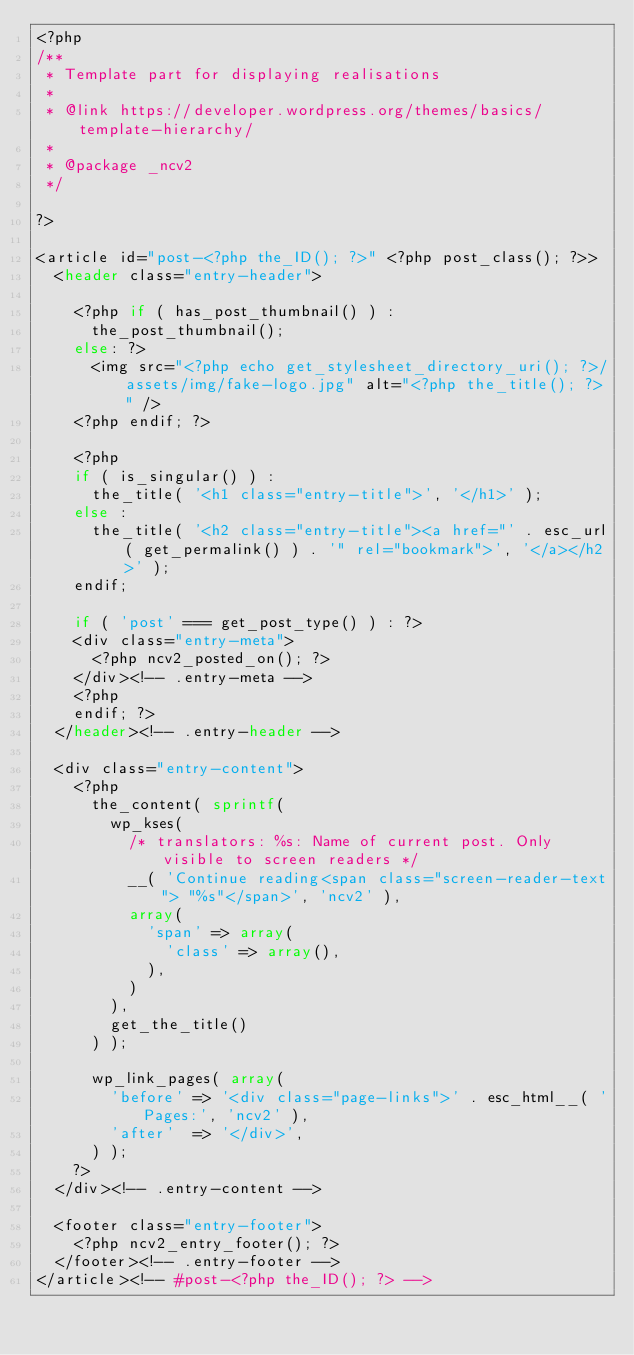Convert code to text. <code><loc_0><loc_0><loc_500><loc_500><_PHP_><?php
/**
 * Template part for displaying realisations
 *
 * @link https://developer.wordpress.org/themes/basics/template-hierarchy/
 *
 * @package _ncv2
 */

?>

<article id="post-<?php the_ID(); ?>" <?php post_class(); ?>>
	<header class="entry-header">

    <?php if ( has_post_thumbnail() ) :
      the_post_thumbnail();
    else: ?>
      <img src="<?php echo get_stylesheet_directory_uri(); ?>/assets/img/fake-logo.jpg" alt="<?php the_title(); ?>" />
    <?php endif; ?>

		<?php
		if ( is_singular() ) :
			the_title( '<h1 class="entry-title">', '</h1>' );
		else :
			the_title( '<h2 class="entry-title"><a href="' . esc_url( get_permalink() ) . '" rel="bookmark">', '</a></h2>' );
		endif;

		if ( 'post' === get_post_type() ) : ?>
		<div class="entry-meta">
			<?php ncv2_posted_on(); ?>
		</div><!-- .entry-meta -->
		<?php
		endif; ?>
	</header><!-- .entry-header -->

	<div class="entry-content">
		<?php
			the_content( sprintf(
				wp_kses(
					/* translators: %s: Name of current post. Only visible to screen readers */
					__( 'Continue reading<span class="screen-reader-text"> "%s"</span>', 'ncv2' ),
					array(
						'span' => array(
							'class' => array(),
						),
					)
				),
				get_the_title()
			) );

			wp_link_pages( array(
				'before' => '<div class="page-links">' . esc_html__( 'Pages:', 'ncv2' ),
				'after'  => '</div>',
			) );
		?>
	</div><!-- .entry-content -->

	<footer class="entry-footer">
		<?php ncv2_entry_footer(); ?>
	</footer><!-- .entry-footer -->
</article><!-- #post-<?php the_ID(); ?> -->
</code> 